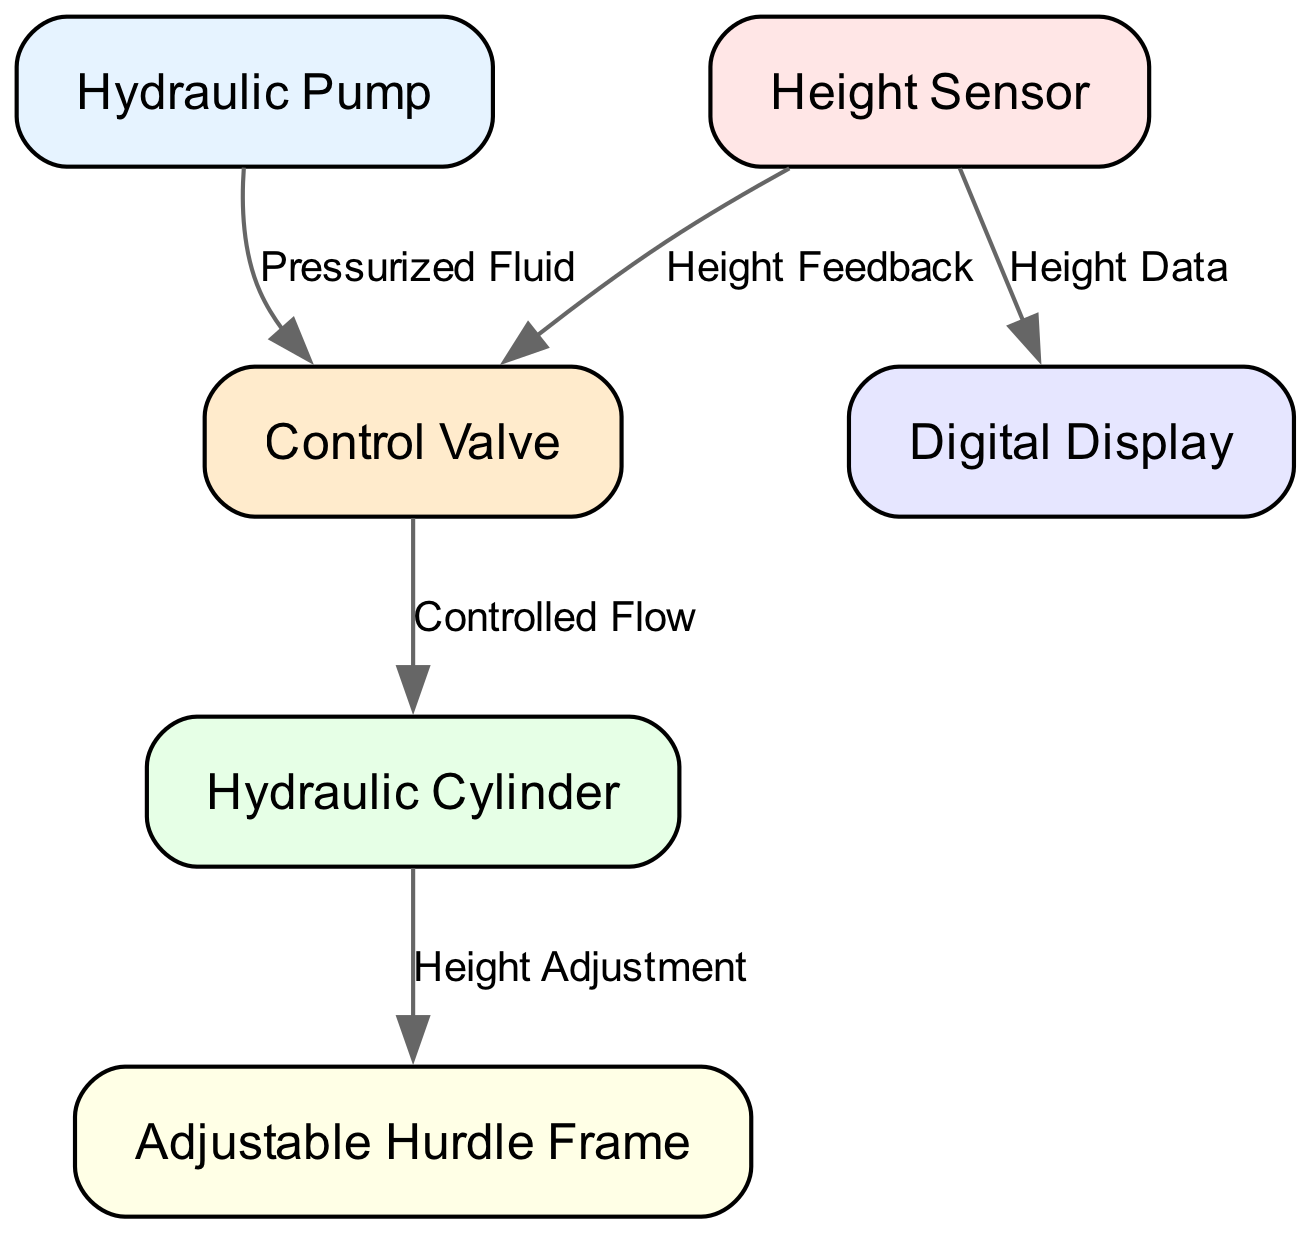What is the total number of nodes in the diagram? The total number of nodes listed in the diagram is six, referring to the components of the hydraulic system like the Hydraulic Pump, Control Valve, etc.
Answer: 6 What is the label of the node that connects with the Control Valve? The node that connects with the Control Valve is the Hydraulic Cylinder, which receives the controlled flow from the valve.
Answer: Hydraulic Cylinder What type of feedback does the Height Sensor provide? The Height Sensor provides Height Feedback to the Control Valve, indicating the current height status of the hurdle.
Answer: Height Feedback Which node receives Height Data from the Height Sensor? The Digital Display receives Height Data from the Height Sensor, allowing users to visually monitor the current height of the hurdle.
Answer: Digital Display How many edges originate from the Hydraulic Pump? There is one edge that originates from the Hydraulic Pump, which conveys pressurized fluid to the Control Valve.
Answer: 1 What mechanism does the Hydraulic Cylinder control? The Hydraulic Cylinder controls the Height Adjustment of the Adjustable Hurdle Frame, translating fluid pressure changes into physical height modification.
Answer: Height Adjustment Which elements are connected by the Controlled Flow edge? The Controlled Flow edge connects the Control Valve to the Hydraulic Cylinder, indicating the flow of hydraulic fluid managed by the valve.
Answer: Control Valve and Hydraulic Cylinder What type of system is represented in this diagram? The diagram represents a hydraulic system designed for precise adjustment of hurdle heights using fluid mechanisms.
Answer: Hydraulic system In total, how many edges link different nodes together in the diagram? The total number of edges in the diagram is five, representing connections and flows between various components of the hydraulic system.
Answer: 5 